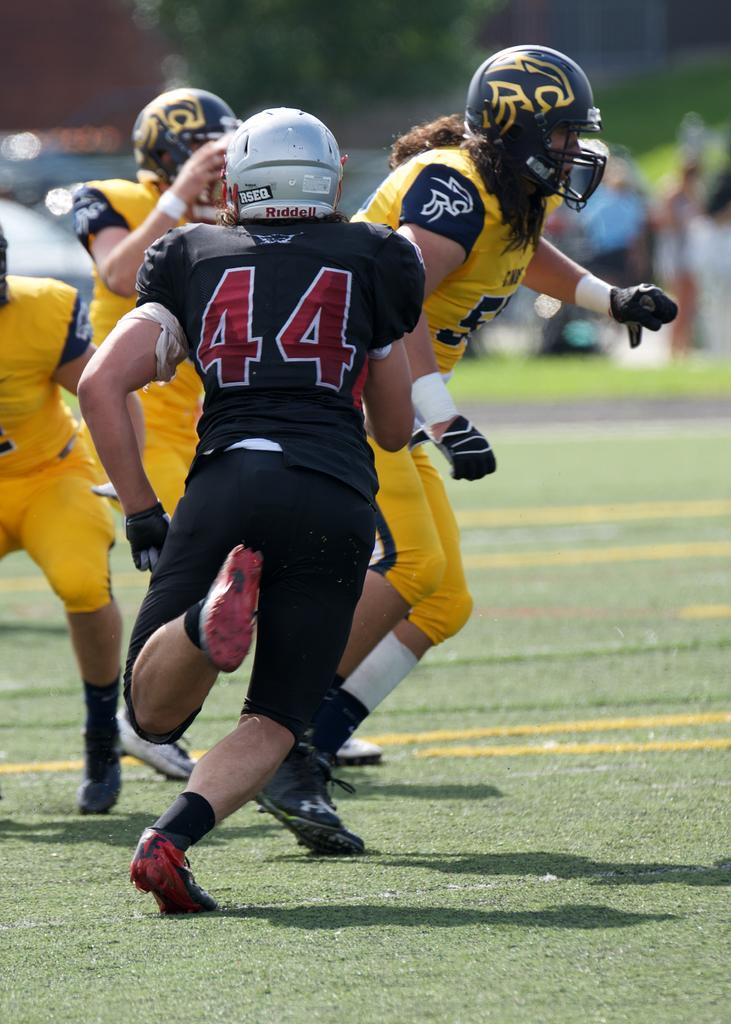How would you summarize this image in a sentence or two? In the front of the image I can see people and grass. These people wore helmets. In the background of the image it is blurry and we can see a tree and people.  